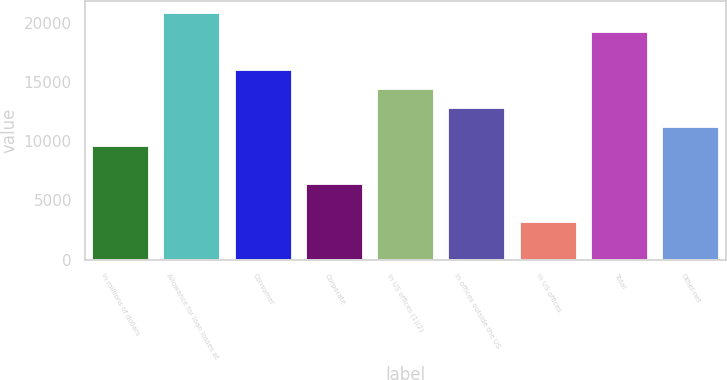Convert chart. <chart><loc_0><loc_0><loc_500><loc_500><bar_chart><fcel>In millions of dollars<fcel>Allowance for loan losses at<fcel>Consumer<fcel>Corporate<fcel>In US offices (1)(2)<fcel>In offices outside the US<fcel>In US offices<fcel>Total<fcel>Other-net<nl><fcel>9597.2<fcel>20791.5<fcel>15994<fcel>6398.82<fcel>14394.8<fcel>12795.6<fcel>3200.44<fcel>19192.3<fcel>11196.4<nl></chart> 